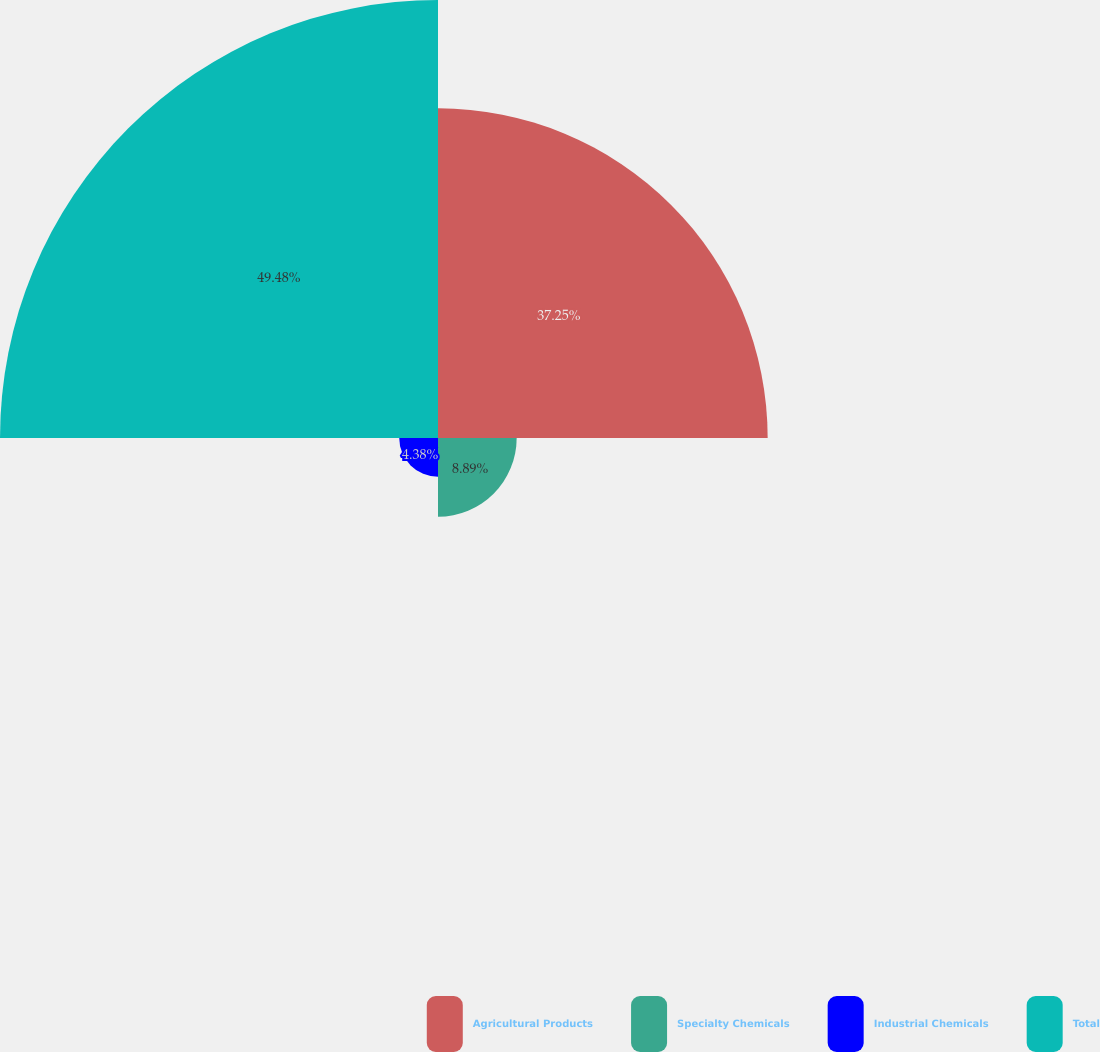Convert chart to OTSL. <chart><loc_0><loc_0><loc_500><loc_500><pie_chart><fcel>Agricultural Products<fcel>Specialty Chemicals<fcel>Industrial Chemicals<fcel>Total<nl><fcel>37.25%<fcel>8.89%<fcel>4.38%<fcel>49.49%<nl></chart> 